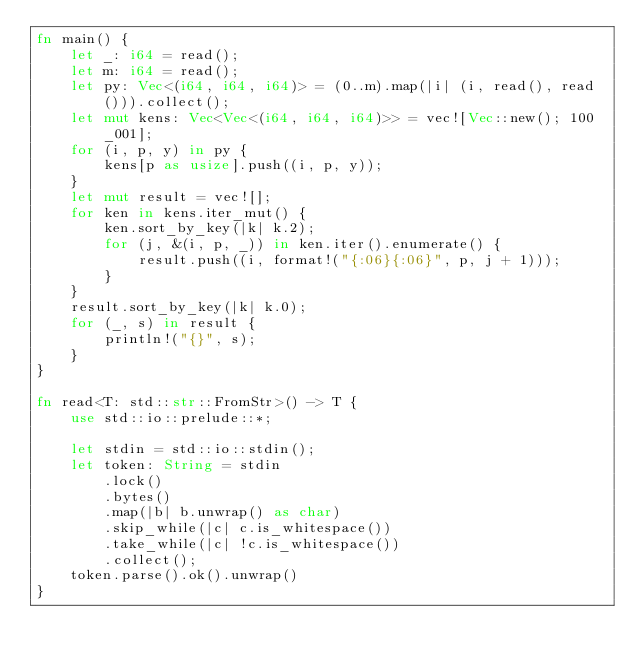Convert code to text. <code><loc_0><loc_0><loc_500><loc_500><_Rust_>fn main() {
    let _: i64 = read();
    let m: i64 = read();
    let py: Vec<(i64, i64, i64)> = (0..m).map(|i| (i, read(), read())).collect();
    let mut kens: Vec<Vec<(i64, i64, i64)>> = vec![Vec::new(); 100_001];
    for (i, p, y) in py {
        kens[p as usize].push((i, p, y));
    }
    let mut result = vec![];
    for ken in kens.iter_mut() {
        ken.sort_by_key(|k| k.2);
        for (j, &(i, p, _)) in ken.iter().enumerate() {
            result.push((i, format!("{:06}{:06}", p, j + 1)));
        }
    }
    result.sort_by_key(|k| k.0);
    for (_, s) in result {
        println!("{}", s);
    }
}

fn read<T: std::str::FromStr>() -> T {
    use std::io::prelude::*;

    let stdin = std::io::stdin();
    let token: String = stdin
        .lock()
        .bytes()
        .map(|b| b.unwrap() as char)
        .skip_while(|c| c.is_whitespace())
        .take_while(|c| !c.is_whitespace())
        .collect();
    token.parse().ok().unwrap()
}
</code> 